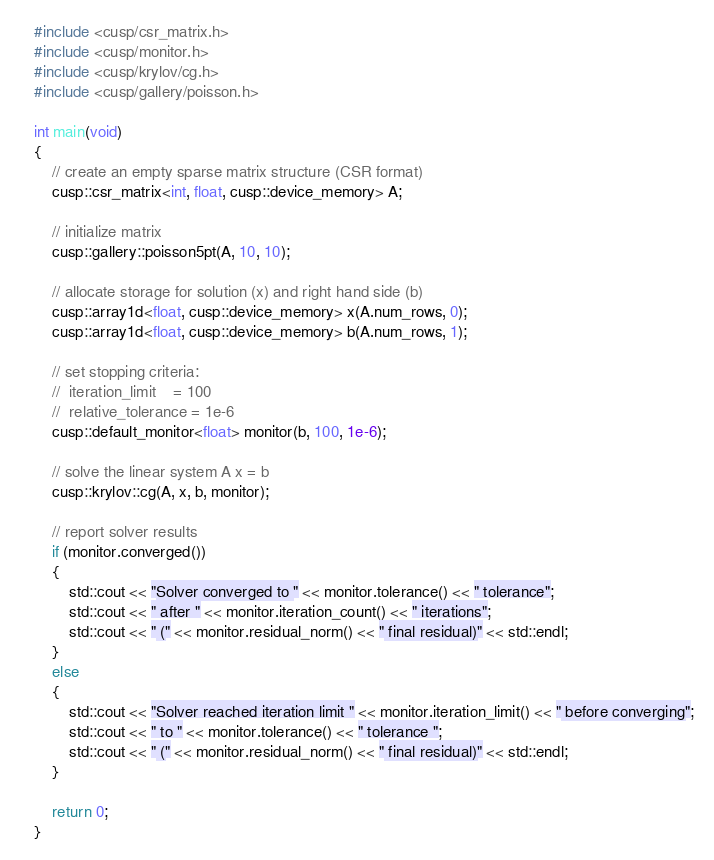Convert code to text. <code><loc_0><loc_0><loc_500><loc_500><_Cuda_>#include <cusp/csr_matrix.h>
#include <cusp/monitor.h>
#include <cusp/krylov/cg.h>
#include <cusp/gallery/poisson.h>

int main(void)
{
    // create an empty sparse matrix structure (CSR format)
    cusp::csr_matrix<int, float, cusp::device_memory> A;

    // initialize matrix
    cusp::gallery::poisson5pt(A, 10, 10);

    // allocate storage for solution (x) and right hand side (b)
    cusp::array1d<float, cusp::device_memory> x(A.num_rows, 0);
    cusp::array1d<float, cusp::device_memory> b(A.num_rows, 1);

    // set stopping criteria:
    //  iteration_limit    = 100
    //  relative_tolerance = 1e-6
    cusp::default_monitor<float> monitor(b, 100, 1e-6);

    // solve the linear system A x = b
    cusp::krylov::cg(A, x, b, monitor);

    // report solver results
    if (monitor.converged())
    {
        std::cout << "Solver converged to " << monitor.tolerance() << " tolerance";
        std::cout << " after " << monitor.iteration_count() << " iterations";
        std::cout << " (" << monitor.residual_norm() << " final residual)" << std::endl;
    }
    else
    {
        std::cout << "Solver reached iteration limit " << monitor.iteration_limit() << " before converging";
        std::cout << " to " << monitor.tolerance() << " tolerance ";
        std::cout << " (" << monitor.residual_norm() << " final residual)" << std::endl;
    }

    return 0;
}

</code> 